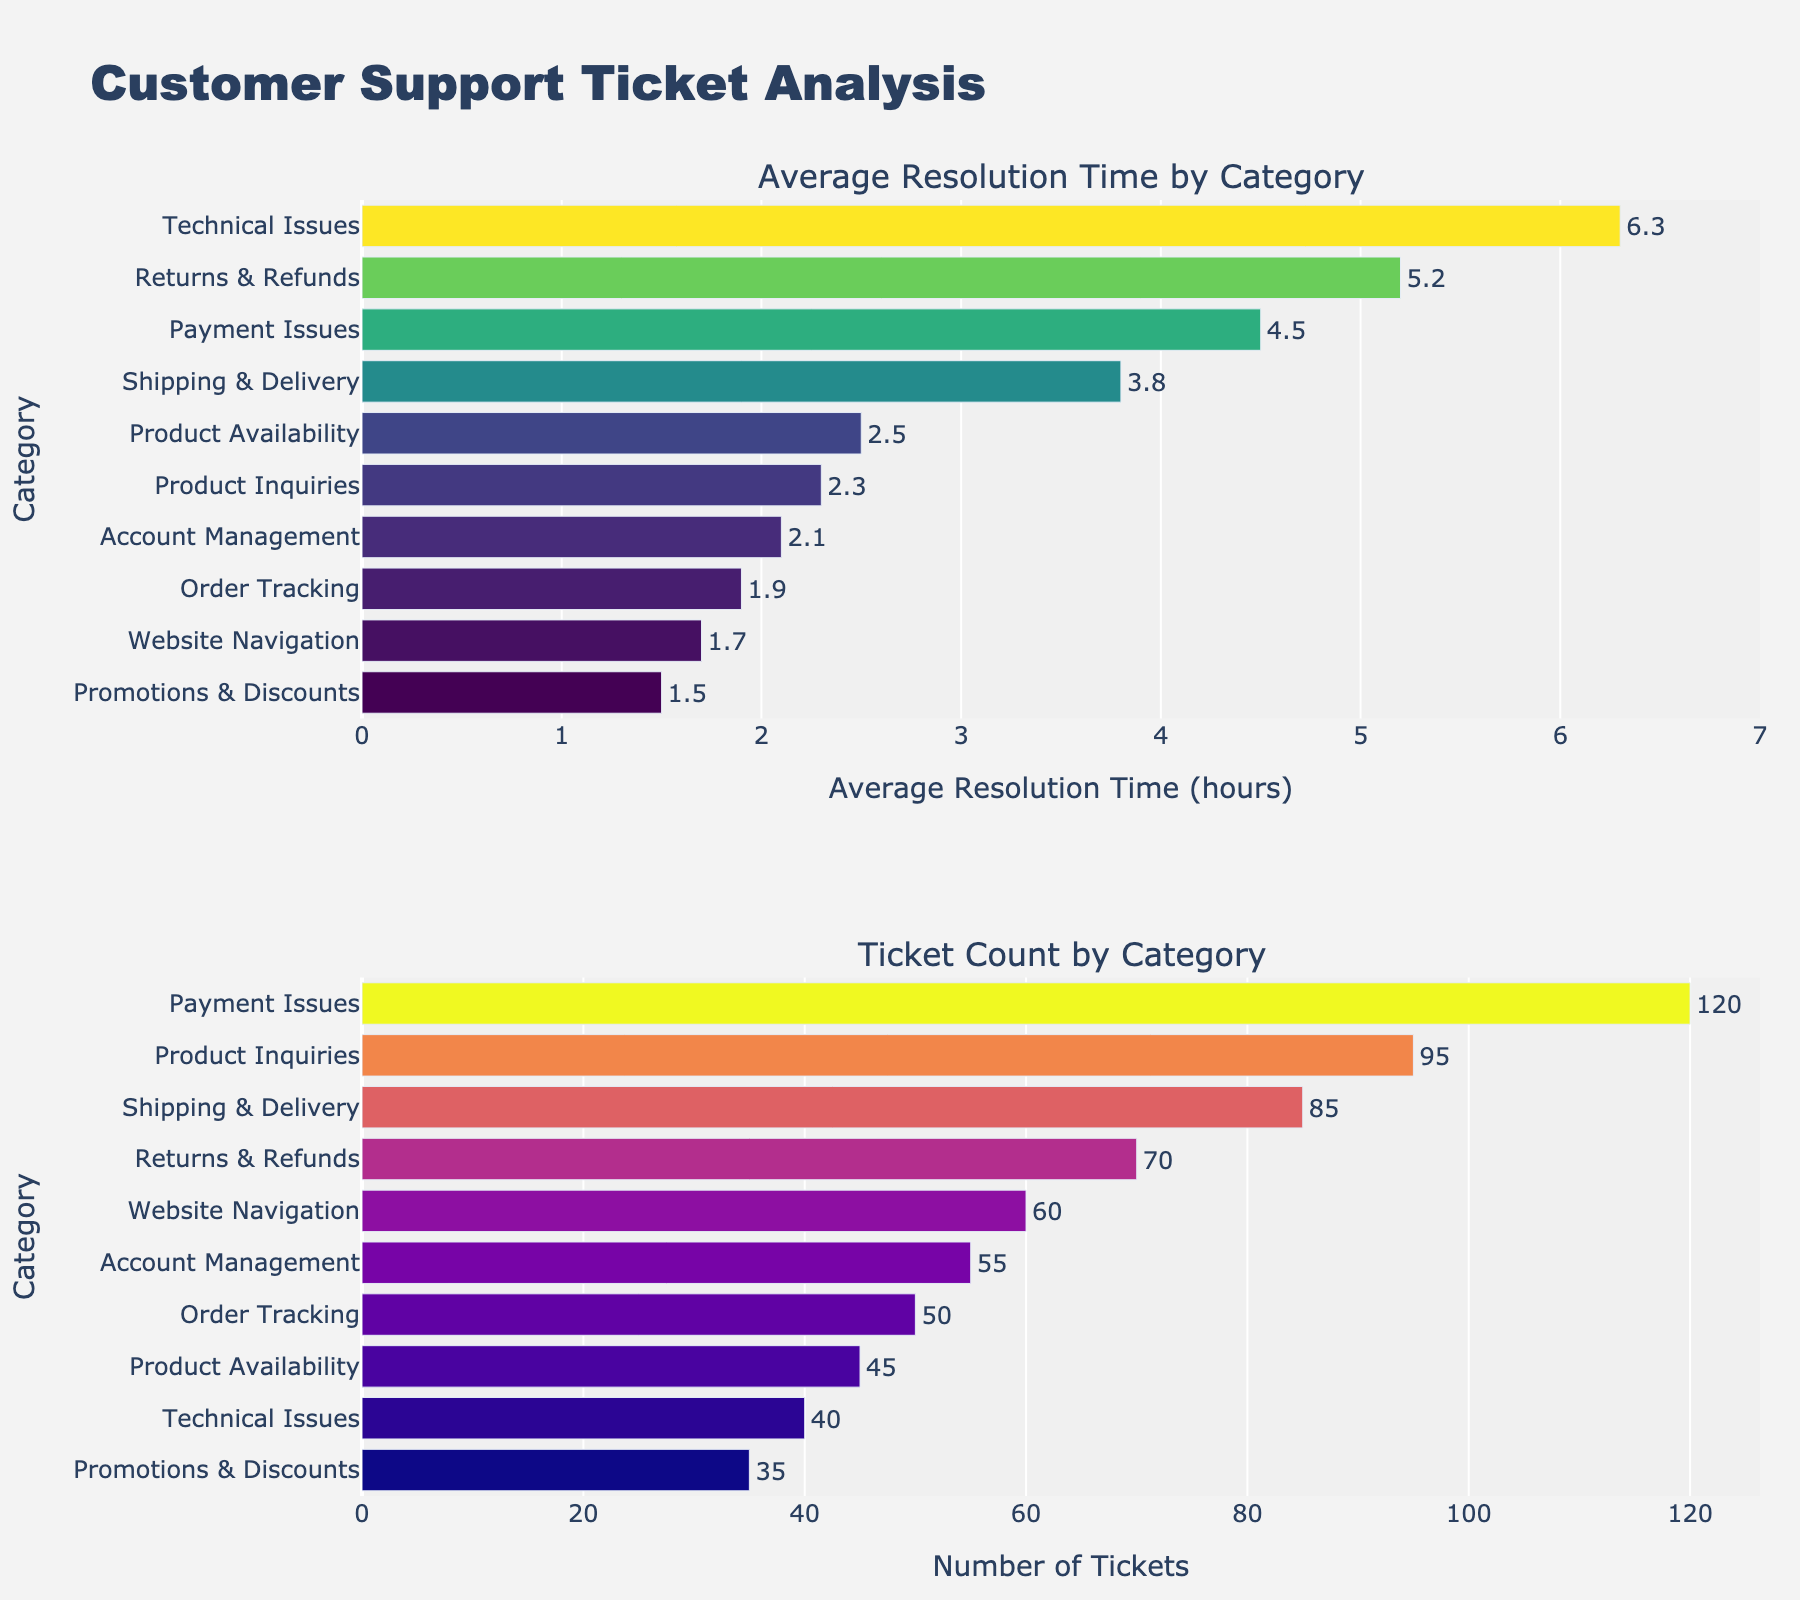What is the category with the longest average resolution time? The first subplot shows bars ordered by average resolution time in descending order. The leftmost bar represents the longest average resolution time. The longest bar is for "Technical Issues" at approximately 6.3 hours.
Answer: Technical Issues Which category has the highest ticket count? The second subplot is sorted in descending order of ticket count. The leftmost bar indicates the category with the highest ticket count. The highest count is for "Payment Issues" with 120 tickets.
Answer: Payment Issues What is the average resolution time for "Returns & Refunds"? In the first subplot, find the bar labeled "Returns & Refunds". Its bar has a text showing its average resolution time is 5.2 hours.
Answer: 5.2 hours Which category has fewer tickets than "Product Inquiries" but more tickets than "Technical Issues"? Referencing the ticket count subplot, "Product Inquiries" has 95 tickets, and "Technical Issues" has 40. "Shipping & Delivery" fits this range with 85 tickets.
Answer: Shipping & Delivery What is the combined average resolution time of "Order Tracking" and "Promotions & Discounts"? The average resolution times for "Order Tracking" and "Promotions & Discounts" are 1.9 hours and 1.5 hours, respectively. By adding them, the combined average is 1.9 + 1.5 = 3.4 hours.
Answer: 3.4 hours Compare the average resolution times of "Payment Issues" and "Shipping & Delivery". Which one is longer? Find the bars for "Payment Issues" and "Shipping & Delivery" in the first subplot. "Payment Issues" has an average resolution time of 4.5 hours, and "Shipping & Delivery" is 3.8 hours, so "Payment Issues" is longer.
Answer: Payment Issues Are there more tickets for "Account Management" or "Order Tracking"? In the second subplot, look at the heights of the bars for "Account Management" and "Order Tracking". "Account Management" has 55 tickets, while "Order Tracking" has 50, so "Account Management" has more.
Answer: Account Management What category has the lowest average resolution time, and what is the value? In the first subplot, the bar at the very bottom represents the lowest average resolution time. "Promotions & Discounts" has the lowest at 1.5 hours.
Answer: Promotions & Discounts Which category has a higher ticket count: "Returns & Refunds" or "Website Navigation"? Refer to the second subplot. "Returns & Refunds" has 70 tickets, while "Website Navigation" has 60. Thus, "Returns & Refunds" has a higher ticket count.
Answer: Returns & Refunds 